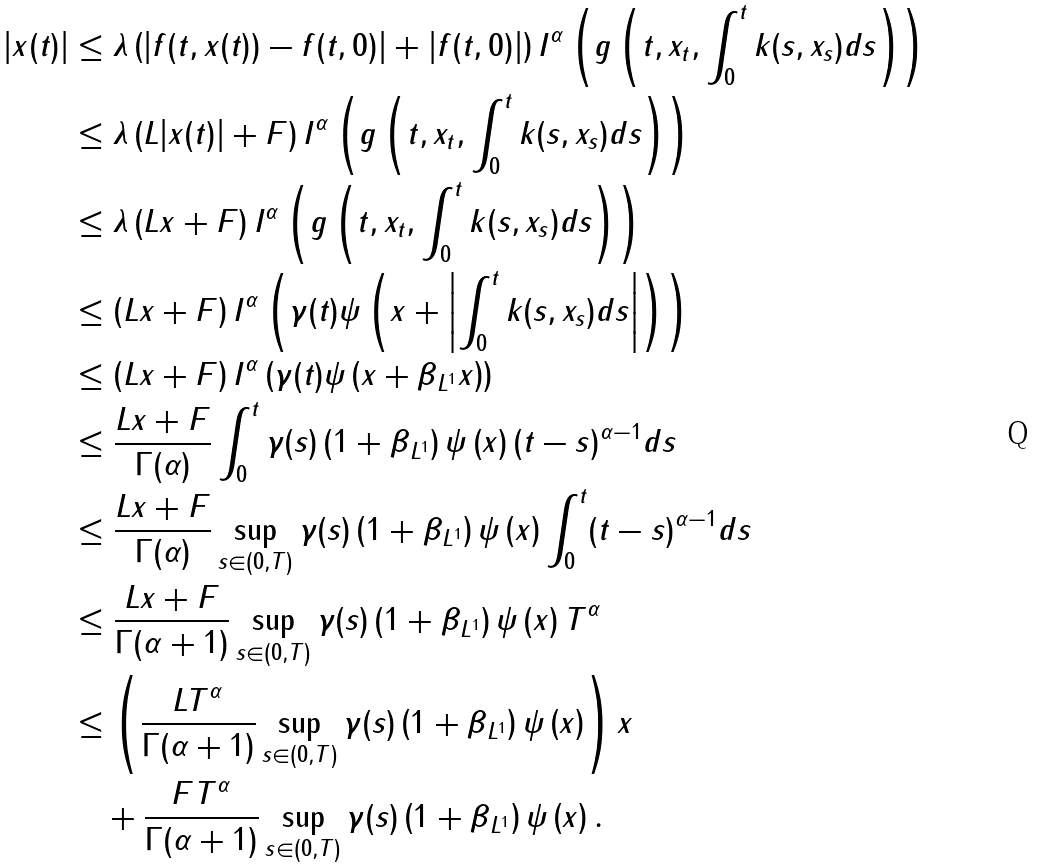<formula> <loc_0><loc_0><loc_500><loc_500>| x ( t ) | & \leq \lambda \left ( | f ( t , x ( t ) ) - f ( t , 0 ) | + | f ( t , 0 ) | \right ) I ^ { \alpha } \left ( g \left ( t , x _ { t } , \int _ { 0 } ^ { t } k ( s , x _ { s } ) d s \right ) \right ) \\ & \leq \lambda \left ( L | x ( t ) | + F \right ) I ^ { \alpha } \left ( g \left ( t , x _ { t } , \int _ { 0 } ^ { t } k ( s , x _ { s } ) d s \right ) \right ) \\ & \leq \lambda \left ( L \| x \| + F \right ) I ^ { \alpha } \left ( g \left ( t , x _ { t } , \int _ { 0 } ^ { t } k ( s , x _ { s } ) d s \right ) \right ) \\ & \leq \left ( L \| x \| + F \right ) I ^ { \alpha } \left ( \gamma ( t ) \psi \left ( \| x \| + \left | \int _ { 0 } ^ { t } k ( s , x _ { s } ) d s \right | \right ) \right ) \\ & \leq \left ( L \| x \| + F \right ) I ^ { \alpha } \left ( \gamma ( t ) \psi \left ( \| x \| + \| \beta \| _ { L ^ { 1 } } \| x \| \right ) \right ) \\ & \leq \frac { L \| x \| + F } { \Gamma ( \alpha ) } \int _ { 0 } ^ { t } \gamma ( s ) \left ( 1 + \| \beta \| _ { L ^ { 1 } } \right ) \psi \left ( \| x \| \right ) ( t - s ) ^ { \alpha - 1 } d s \\ & \leq \frac { L \| x \| + F } { \Gamma ( \alpha ) } \sup _ { s \in ( 0 , T ) } \gamma ( s ) \left ( 1 + \| \beta \| _ { L ^ { 1 } } \right ) \psi \left ( \| x \| \right ) \int _ { 0 } ^ { t } ( t - s ) ^ { \alpha - 1 } d s \\ & \leq \frac { L \| x \| + F } { \Gamma ( \alpha + 1 ) } \sup _ { s \in ( 0 , T ) } \gamma ( s ) \left ( 1 + \| \beta \| _ { L ^ { 1 } } \right ) \psi \left ( \| x \| \right ) T ^ { \alpha } \\ & \leq \left ( \frac { L T ^ { \alpha } } { \Gamma ( \alpha + 1 ) } \sup _ { s \in ( 0 , T ) } \gamma ( s ) \left ( 1 + \| \beta \| _ { L ^ { 1 } } \right ) \psi \left ( \| x \| \right ) \right ) \| x \| \\ & \quad + \frac { F T ^ { \alpha } } { \Gamma ( \alpha + 1 ) } \sup _ { s \in ( 0 , T ) } \gamma ( s ) \left ( 1 + \| \beta \| _ { L ^ { 1 } } \right ) \psi \left ( \| x \| \right ) .</formula> 